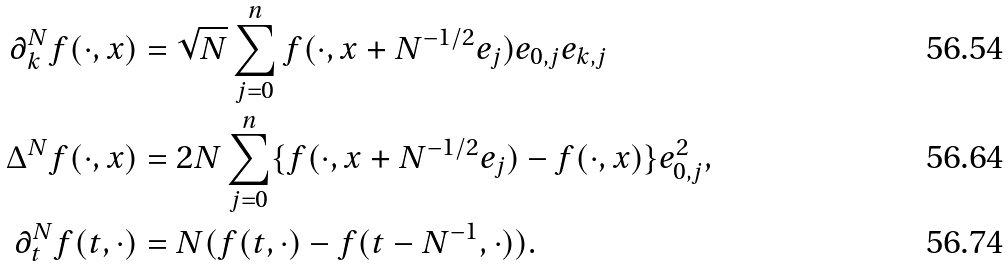Convert formula to latex. <formula><loc_0><loc_0><loc_500><loc_500>\partial _ { k } ^ { N } f ( \cdot , x ) & = \sqrt { N } \sum _ { j = 0 } ^ { n } f ( \cdot , x + N ^ { - 1 / 2 } e _ { j } ) e _ { 0 , j } e _ { k , j } \\ \Delta ^ { N } f ( \cdot , x ) & = 2 { N } \sum _ { j = 0 } ^ { n } \{ f ( \cdot , x + N ^ { - 1 / 2 } e _ { j } ) - f ( \cdot , x ) \} e _ { 0 , j } ^ { 2 } , \\ \partial ^ { N } _ { t } f ( t , \cdot ) & = N ( f ( t , \cdot ) - f ( t - N ^ { - 1 } , \cdot ) ) .</formula> 